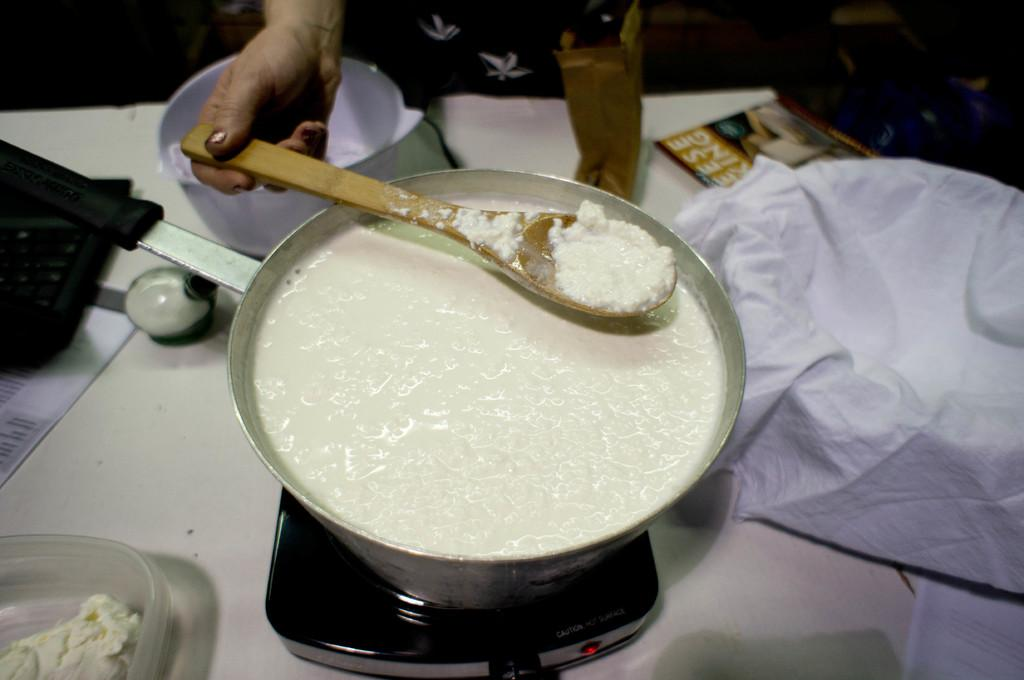<image>
Offer a succinct explanation of the picture presented. A woman pulls out a spoon of white goo from a pot on a hot plate with the word "caution" on it. 